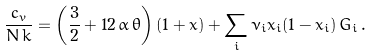<formula> <loc_0><loc_0><loc_500><loc_500>\frac { c _ { v } } { N \, k } = \left ( \frac { 3 } { 2 } + 1 2 \, \alpha \, \theta \right ) ( 1 + \bar { x } ) + \sum _ { i } \nu _ { i } x _ { i } ( 1 - x _ { i } ) \, G _ { i } \, .</formula> 